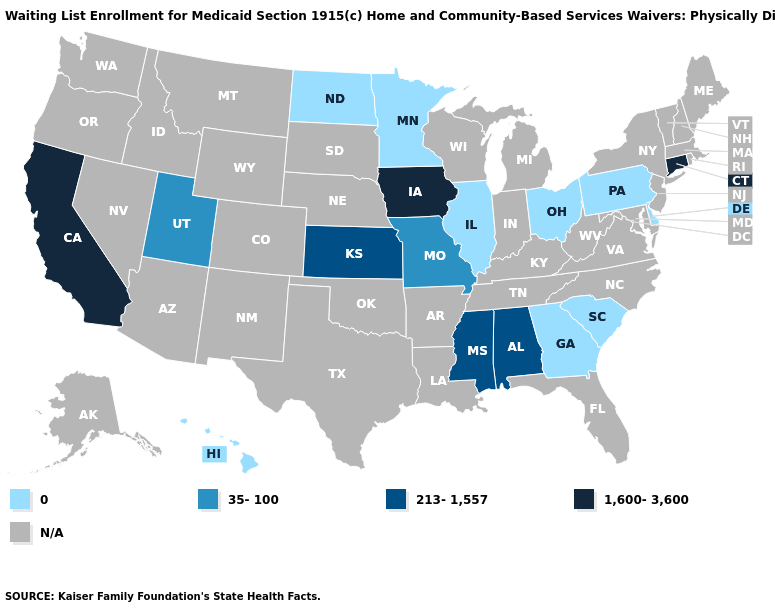What is the value of New York?
Answer briefly. N/A. What is the value of Alaska?
Quick response, please. N/A. What is the lowest value in the USA?
Keep it brief. 0. How many symbols are there in the legend?
Be succinct. 5. Which states have the highest value in the USA?
Quick response, please. California, Connecticut, Iowa. Name the states that have a value in the range 0?
Short answer required. Delaware, Georgia, Hawaii, Illinois, Minnesota, North Dakota, Ohio, Pennsylvania, South Carolina. Is the legend a continuous bar?
Concise answer only. No. What is the value of Delaware?
Keep it brief. 0. What is the value of Washington?
Short answer required. N/A. Which states have the lowest value in the South?
Quick response, please. Delaware, Georgia, South Carolina. What is the value of Massachusetts?
Quick response, please. N/A. 